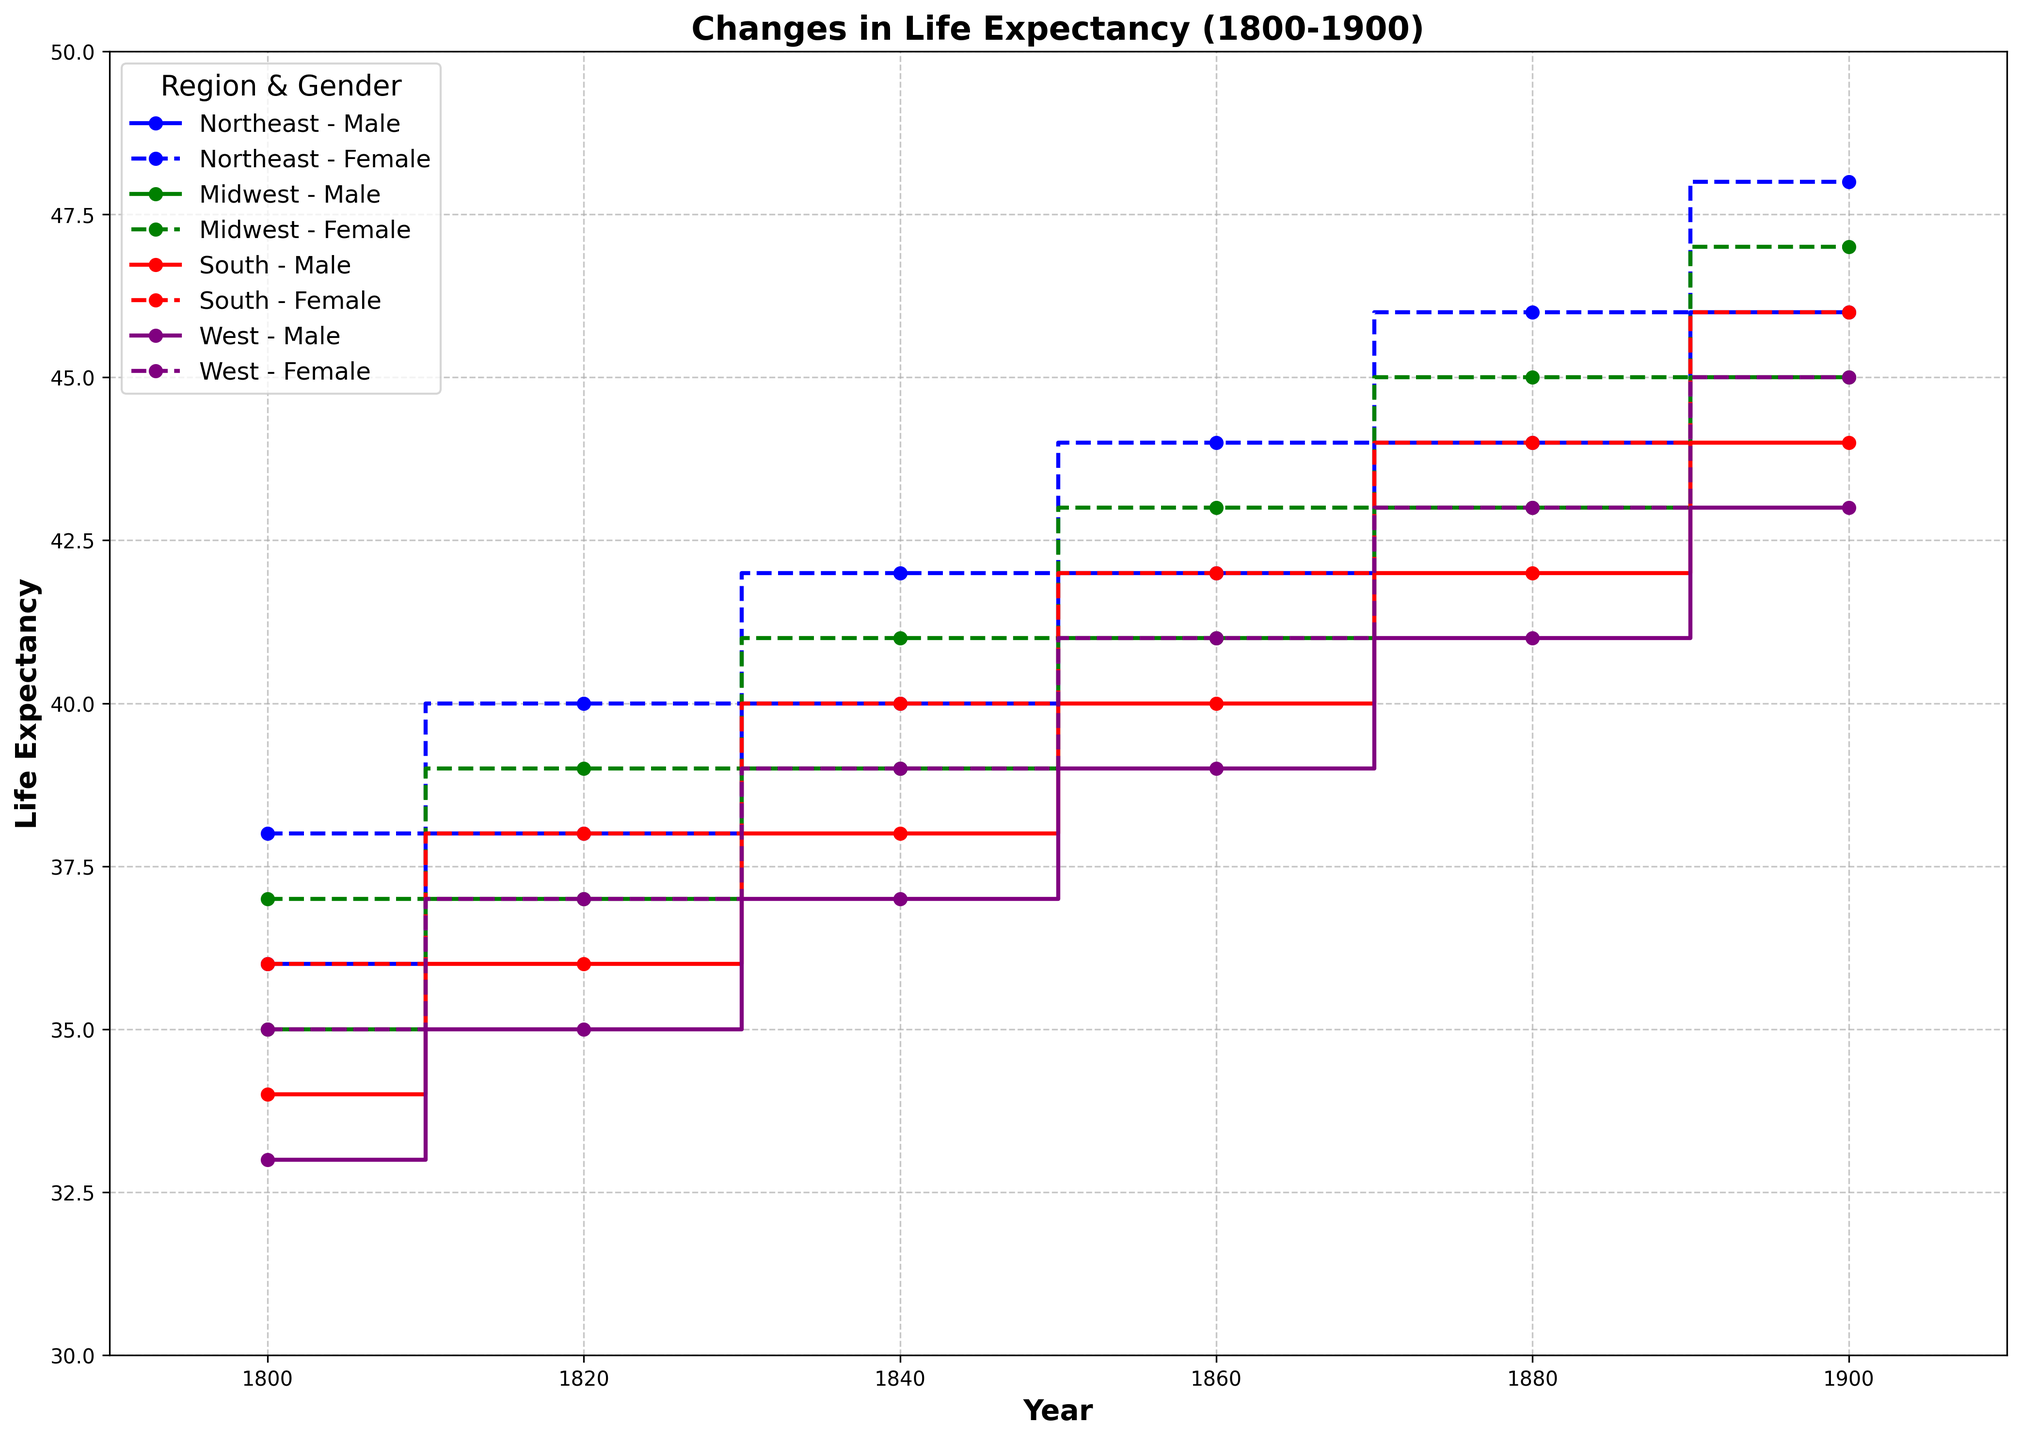which region experienced the highest increase in life expectancy for males between 1800 and 1900? First, identify the starting and ending life expectancy values for males in each region from 1800 and 1900. Then, calculate the increase for each region by subtracting the 1800 value from the 1900 value. The region with the highest difference is the answer: Northeast (46 - 36 = 10), Midwest (45 - 35 = 10), South (44 - 34 = 10), West (43 - 33 = 10). All regions have the same increase.
Answer: All regions What is the life expectancy difference between females in the Northeast and the South in 1900? Find the life expectancy values for females in the Northeast and South in 1900 and subtract the latter from the former: Northeast (48) - South (46) = 2.
Answer: 2 Which region had the lowest life expectancy for males in 1860? Look at the life expectancy values for males in each region in 1860: Northeast (42), Midwest (41), South (40), West (39). The West has the lowest value.
Answer: West In which year do males in the West catch up to the female life expectancy in the South? For each year, compare the life expectancy of West males and South females. West male life expectancy catches up to South female life expectancy in 1880, both being 41.
Answer: 1880 What was the average life expectancy for females in the Midwest across all the years provided? Sum the life expectancy values for females in the Midwest for all years and divide by the number of years: (37 + 39 + 41 + 43 + 45 + 47)/6 = 42
Answer: 42 How much did the life expectancy for females in the Northeast increase from 1800 to 1900? Subtract the life expectancy value for Northeast females in 1800 from that in 1900: 48 - 38 = 10.
Answer: 10 Compare the changes in life expectancy for males and females in the South between 1800 and 1900. What can you infer? Calculate the increase for males: 44 - 34 = 10, and for females: 46 - 36 = 10. The increase is the same for both genders, indicating parallel improvements for males and females in the South.
Answer: Parallel improvements 